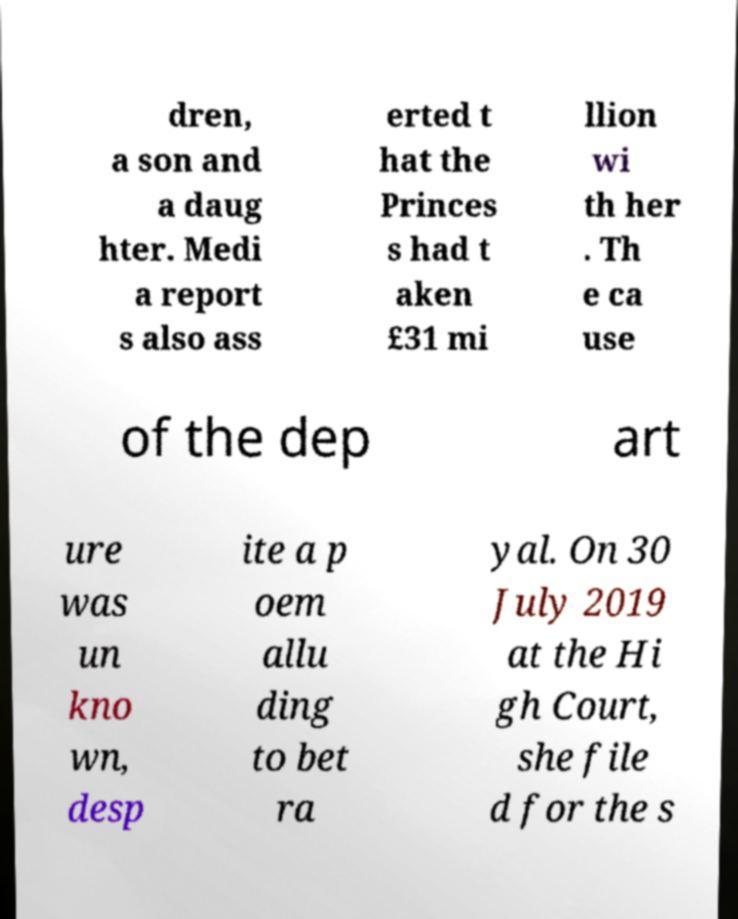What messages or text are displayed in this image? I need them in a readable, typed format. dren, a son and a daug hter. Medi a report s also ass erted t hat the Princes s had t aken £31 mi llion wi th her . Th e ca use of the dep art ure was un kno wn, desp ite a p oem allu ding to bet ra yal. On 30 July 2019 at the Hi gh Court, she file d for the s 